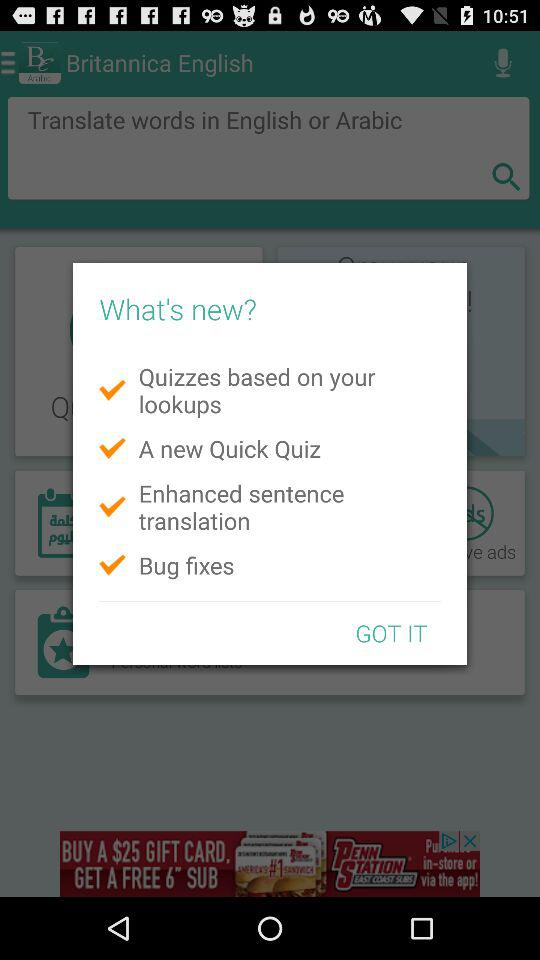What are the new features? The new features are "Quizzes based on your lookups", "A new Quick Quiz", "Enhanced sentence translation" and "Bug fixes". 